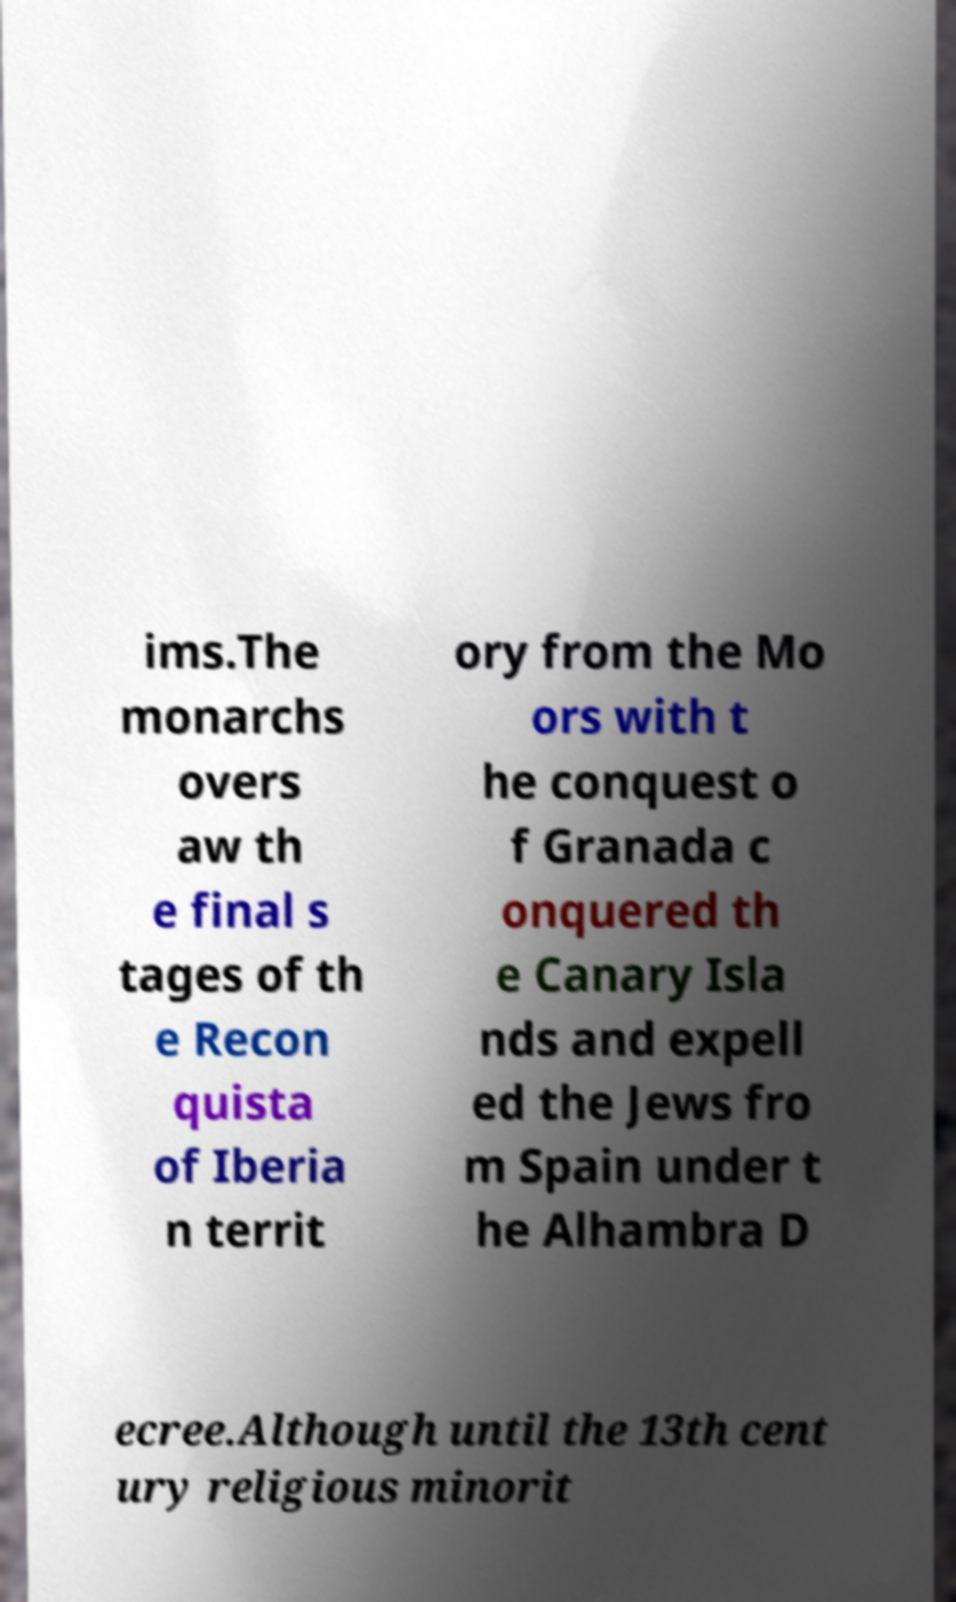There's text embedded in this image that I need extracted. Can you transcribe it verbatim? ims.The monarchs overs aw th e final s tages of th e Recon quista of Iberia n territ ory from the Mo ors with t he conquest o f Granada c onquered th e Canary Isla nds and expell ed the Jews fro m Spain under t he Alhambra D ecree.Although until the 13th cent ury religious minorit 